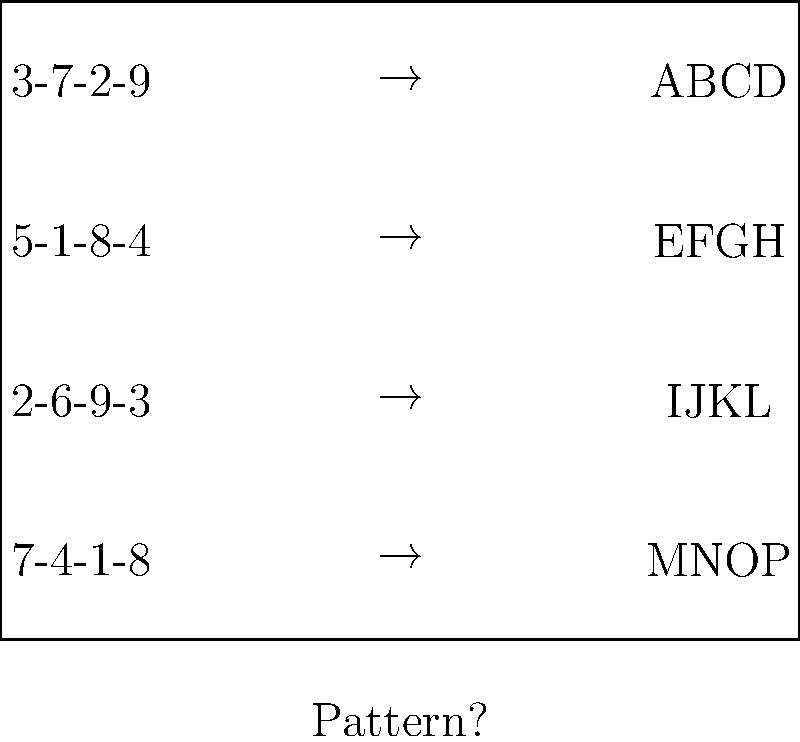Analyze the encoded messages and their corresponding decoded patterns. What would be the most likely decoded pattern for the message "6-2-5-7"? To solve this problem, we need to identify the pattern between the encoded messages and their decoded counterparts:

1. Observe the encoded messages:
   - 3-7-2-9 → ABCD
   - 5-1-8-4 → EFGH
   - 2-6-9-3 → IJKL
   - 7-4-1-8 → MNOP

2. Notice that each number in the encoded message corresponds to a letter in the alphabet:
   - 1 → E, M
   - 2 → A, I
   - 3 → D, L
   - 4 → H, N
   - 5 → E
   - 6 → I
   - 7 → B, M
   - 8 → G, P
   - 9 → C, K

3. The pattern reveals that the numbers represent the position of the letter in the alphabet, cycling through every 4 letters:
   - 1-4 represent A-D, then E-H, then I-L, and finally M-P

4. For the new message "6-2-5-7":
   - 6 represents the 2nd letter in the 3rd group (IJKL) → J
   - 2 represents the 2nd letter in the 1st group (ABCD) → B
   - 5 represents the 1st letter in the 2nd group (EFGH) → E
   - 7 represents the 3rd letter in the 4th group (MNOP) → O

5. Therefore, the decoded pattern for "6-2-5-7" would be JBEO.
Answer: JBEO 